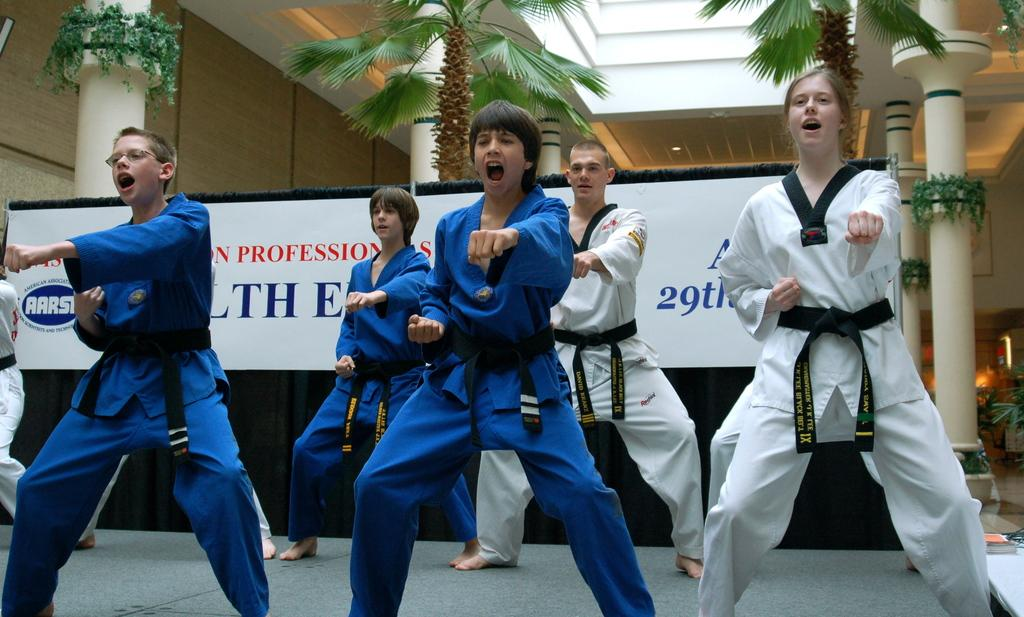What activity are the people in the image engaged in? The people in the image are doing karate. What type of natural elements can be seen in the image? There are trees and plants in the image. What type of artificial lighting is present in the image? There are lights in the image. Is there any text visible in the image? Yes, there is a board with text in the image. Are there any cherries being eaten by the people doing karate in the image? There are no cherries present in the image. Are the people doing karate sisters in the image? There is no information about the relationship between the people doing karate in the image. 